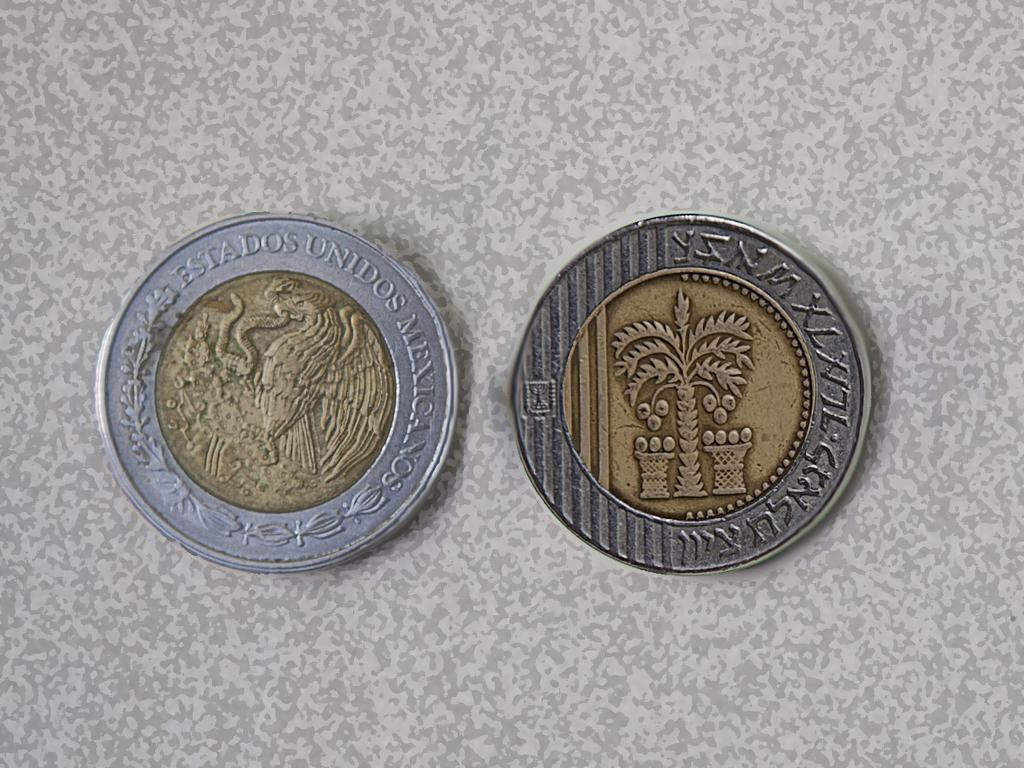What objects are present in the image? There are two coins in the image. Where are the coins located? The coins are placed on a table. What type of structure is visible in the image? There is no structure visible in the image; it only features two coins placed on a table. How many family members can be seen in the image? There are no family members present in the image; it only features two coins placed on a table. 